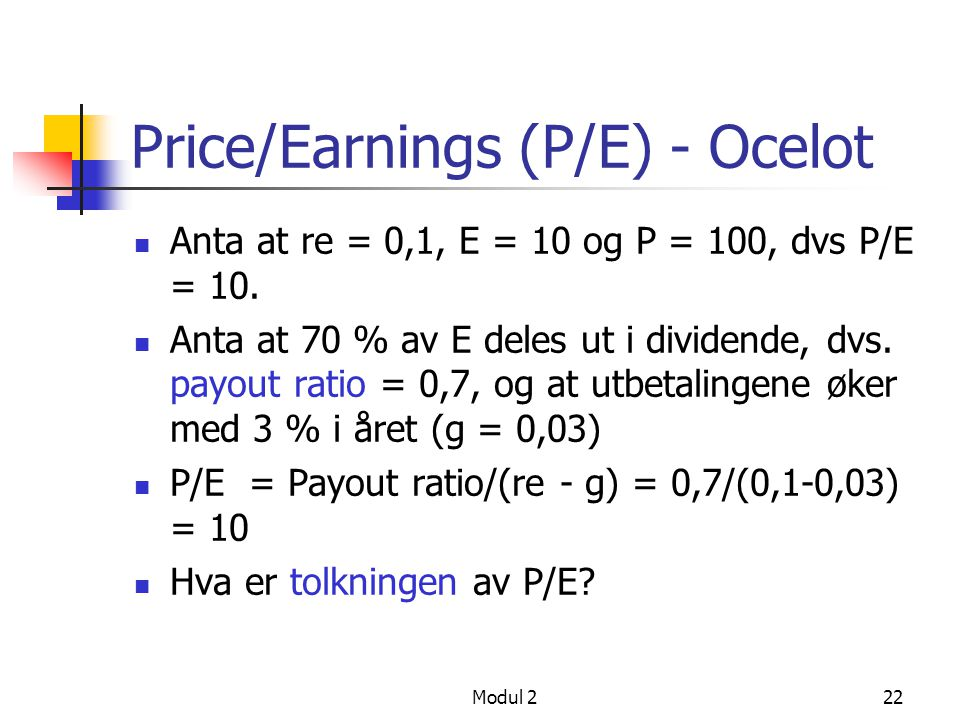In terms of risk, what does a high P/E ratio tell us about a company? A high P/E ratio often indicates that investors are expecting significant future growth from the company. This expectation can be driven by various factors, such as innovative products, market expansion, or strong financial performance. However, a high P/E ratio also implies a higher risk, as it reflects the premium investors are willing to pay for potential future earnings. If the company fails to meet these high expectations, its stock price can be more susceptible to declines. 